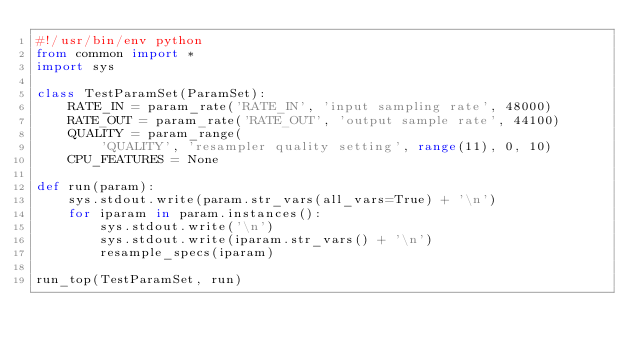Convert code to text. <code><loc_0><loc_0><loc_500><loc_500><_Python_>#!/usr/bin/env python
from common import *
import sys

class TestParamSet(ParamSet):
    RATE_IN = param_rate('RATE_IN', 'input sampling rate', 48000)
    RATE_OUT = param_rate('RATE_OUT', 'output sample rate', 44100)
    QUALITY = param_range(
        'QUALITY', 'resampler quality setting', range(11), 0, 10)
    CPU_FEATURES = None

def run(param):
    sys.stdout.write(param.str_vars(all_vars=True) + '\n')
    for iparam in param.instances():
        sys.stdout.write('\n')
        sys.stdout.write(iparam.str_vars() + '\n')
        resample_specs(iparam)

run_top(TestParamSet, run)
</code> 